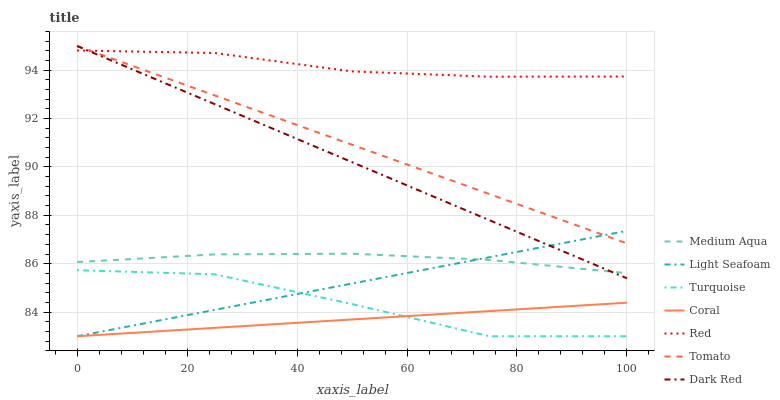Does Coral have the minimum area under the curve?
Answer yes or no. Yes. Does Red have the maximum area under the curve?
Answer yes or no. Yes. Does Turquoise have the minimum area under the curve?
Answer yes or no. No. Does Turquoise have the maximum area under the curve?
Answer yes or no. No. Is Tomato the smoothest?
Answer yes or no. Yes. Is Turquoise the roughest?
Answer yes or no. Yes. Is Turquoise the smoothest?
Answer yes or no. No. Is Dark Red the roughest?
Answer yes or no. No. Does Turquoise have the lowest value?
Answer yes or no. Yes. Does Dark Red have the lowest value?
Answer yes or no. No. Does Dark Red have the highest value?
Answer yes or no. Yes. Does Turquoise have the highest value?
Answer yes or no. No. Is Turquoise less than Red?
Answer yes or no. Yes. Is Tomato greater than Turquoise?
Answer yes or no. Yes. Does Dark Red intersect Tomato?
Answer yes or no. Yes. Is Dark Red less than Tomato?
Answer yes or no. No. Is Dark Red greater than Tomato?
Answer yes or no. No. Does Turquoise intersect Red?
Answer yes or no. No. 